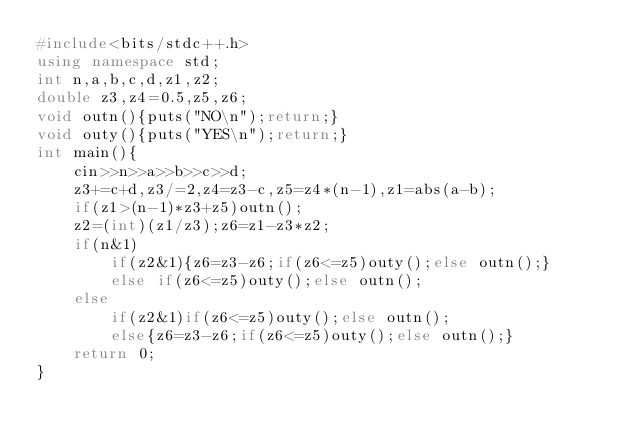<code> <loc_0><loc_0><loc_500><loc_500><_C++_>#include<bits/stdc++.h>
using namespace std;
int n,a,b,c,d,z1,z2;
double z3,z4=0.5,z5,z6;
void outn(){puts("NO\n");return;}
void outy(){puts("YES\n");return;}
int main(){
	cin>>n>>a>>b>>c>>d;
	z3+=c+d,z3/=2,z4=z3-c,z5=z4*(n-1),z1=abs(a-b);
	if(z1>(n-1)*z3+z5)outn();
	z2=(int)(z1/z3);z6=z1-z3*z2;
	if(n&1)
		if(z2&1){z6=z3-z6;if(z6<=z5)outy();else outn();}
		else if(z6<=z5)outy();else outn();
	else
		if(z2&1)if(z6<=z5)outy();else outn();
		else{z6=z3-z6;if(z6<=z5)outy();else outn();}
	return 0;
}</code> 